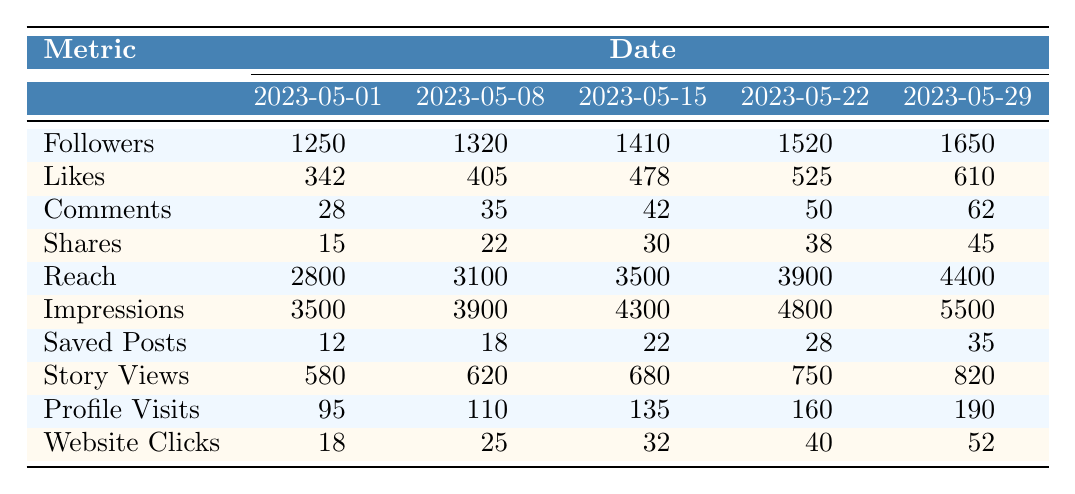What were the followers on May 15? Referring to the table, the number of followers on May 15, 2023, is listed under that date. The value is 1410.
Answer: 1410 What is the total number of likes from May 1 to May 29? To find the total likes, sum the likes for all dates: 342 + 405 + 478 + 525 + 610 = 2360.
Answer: 2360 Did the number of story views increase from May 1 to May 29? Comparing the story views on May 1 (580) and May 29 (820), we see that the number of story views increased.
Answer: Yes What is the difference in the number of reaches between May 22 and May 1? The reach on May 22 is 3900 and on May 1 is 2800. The difference is 3900 - 2800 = 1100.
Answer: 1100 What is the average number of shares for the month? To find the average shares, sum the shares for all dates: 15 + 22 + 30 + 38 + 45 = 150. Then divide by the number of data points (5): 150/5 = 30.
Answer: 30 Which date had the most saved posts? Looking at the saved posts column, May 29 has the highest number of saved posts, which is 35.
Answer: May 29 What was the percentage increase in followers from May 1 to May 29? Followers on May 1 was 1250, and on May 29 it is 1650. The increase is 1650 - 1250 = 400. To find the percentage: (400/1250)*100 = 32%.
Answer: 32% On which date did the account have the highest engagement in terms of comments? By checking the comments for each date, May 29 shows the highest number of comments, which is 62.
Answer: May 29 What is the trend for profile visits over the month? Comparing the profile visits: 95 (May 1), 110 (May 8), 135 (May 15), 160 (May 22), and 190 (May 29), we see an increasing trend.
Answer: Increasing Was the number of website clicks on May 8 higher than on May 1? The number of website clicks on May 8 is 25, and on May 1 it is 18. Since 25 is greater than 18, the answer is yes.
Answer: Yes 